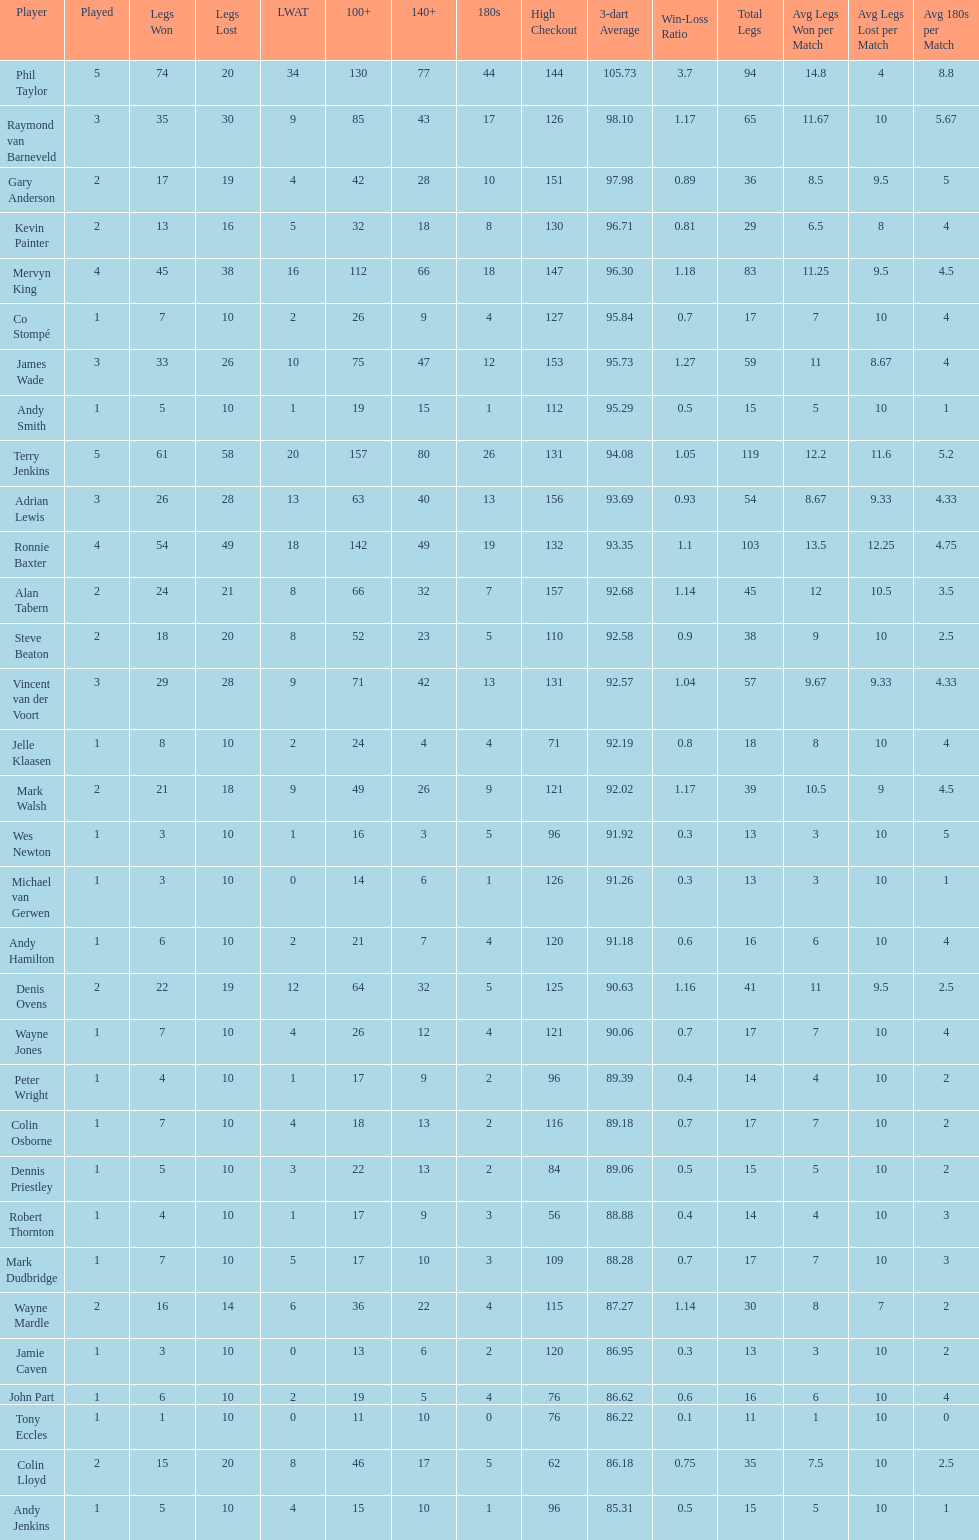List each of the players with a high checkout of 131. Terry Jenkins, Vincent van der Voort. 